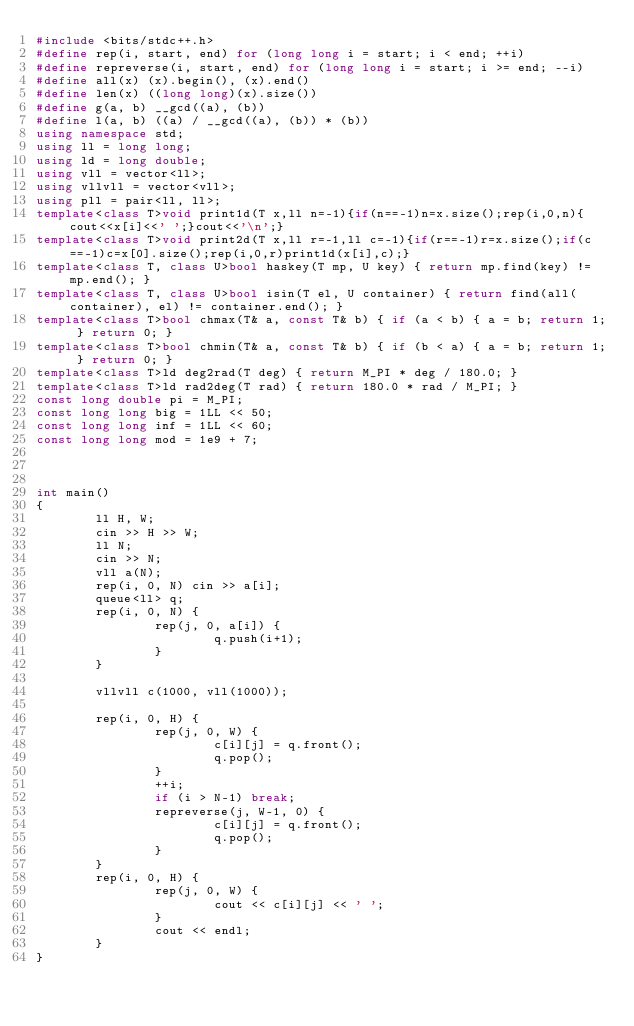Convert code to text. <code><loc_0><loc_0><loc_500><loc_500><_C++_>#include <bits/stdc++.h>
#define rep(i, start, end) for (long long i = start; i < end; ++i)
#define repreverse(i, start, end) for (long long i = start; i >= end; --i)
#define all(x) (x).begin(), (x).end()
#define len(x) ((long long)(x).size())
#define g(a, b) __gcd((a), (b))
#define l(a, b) ((a) / __gcd((a), (b)) * (b))
using namespace std;
using ll = long long;
using ld = long double;
using vll = vector<ll>;
using vllvll = vector<vll>;
using pll = pair<ll, ll>;
template<class T>void print1d(T x,ll n=-1){if(n==-1)n=x.size();rep(i,0,n){cout<<x[i]<<' ';}cout<<'\n';}
template<class T>void print2d(T x,ll r=-1,ll c=-1){if(r==-1)r=x.size();if(c==-1)c=x[0].size();rep(i,0,r)print1d(x[i],c);}
template<class T, class U>bool haskey(T mp, U key) { return mp.find(key) != mp.end(); }
template<class T, class U>bool isin(T el, U container) { return find(all(container), el) != container.end(); }
template<class T>bool chmax(T& a, const T& b) { if (a < b) { a = b; return 1; } return 0; }
template<class T>bool chmin(T& a, const T& b) { if (b < a) { a = b; return 1; } return 0; }
template<class T>ld deg2rad(T deg) { return M_PI * deg / 180.0; }
template<class T>ld rad2deg(T rad) { return 180.0 * rad / M_PI; }
const long double pi = M_PI;
const long long big = 1LL << 50;
const long long inf = 1LL << 60;
const long long mod = 1e9 + 7;



int main()
{
        ll H, W;
        cin >> H >> W;
        ll N;
        cin >> N;
        vll a(N);
        rep(i, 0, N) cin >> a[i];
        queue<ll> q;
        rep(i, 0, N) {
                rep(j, 0, a[i]) {
                        q.push(i+1);
                }
        }

        vllvll c(1000, vll(1000));

        rep(i, 0, H) {
                rep(j, 0, W) {
                        c[i][j] = q.front();
                        q.pop();
                }
                ++i;
                if (i > N-1) break;
                repreverse(j, W-1, 0) {
                        c[i][j] = q.front();
                        q.pop();
                }
        }
        rep(i, 0, H) {
                rep(j, 0, W) {
                        cout << c[i][j] << ' ';
                }
                cout << endl;
        }
}</code> 